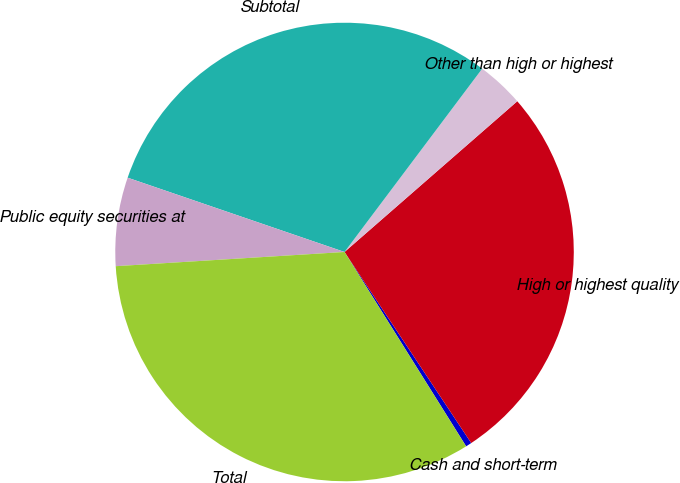Convert chart. <chart><loc_0><loc_0><loc_500><loc_500><pie_chart><fcel>Cash and short-term<fcel>High or highest quality<fcel>Other than high or highest<fcel>Subtotal<fcel>Public equity securities at<fcel>Total<nl><fcel>0.42%<fcel>27.1%<fcel>3.33%<fcel>30.0%<fcel>6.24%<fcel>32.91%<nl></chart> 